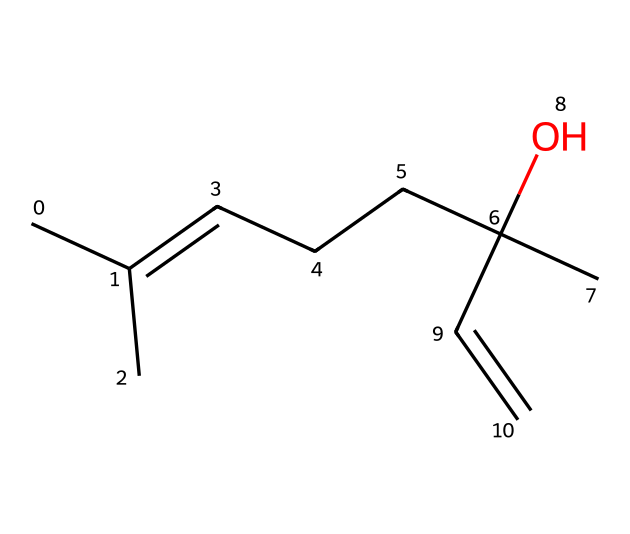What is the molecular formula of linalool? By analyzing the provided SMILES notation, we count the number of each type of atom. The structure indicates there are 10 carbon (C) atoms, 18 hydrogen (H) atoms, and 1 oxygen (O) atom. Therefore, the molecular formula is C10H18O.
Answer: C10H18O How many carbon atoms are present in linalool? Observing the SMILES representation, we can see the number of 'C' indicates the carbon atoms in the structure. Counting the 'C' in the SMILES leads us to a total of 10 carbon atoms.
Answer: 10 What type of functional group is indicated by the "C(O)" part of linalool? The "C(O)" portion in the SMILES notation represents a carbon atom bonded to a hydroxyl group (OH). This indicates the presence of an alcohol functional group in linalool.
Answer: alcohol Is linalool a cyclic or acyclic compound? By examining the structure, we can see there are no ring structures present as indicated by the absence of a cycle in the carbon chain from the SMILES. This confirms that linalool is an acyclic compound.
Answer: acyclic What is the primary reason linalool is used in stress relief? Linalool is commonly known for its calming and relaxing properties due to its interaction with the nervous system and its aromatic profile. This property is primarily linked to its specific arrangement of atoms and bonds which influences how it interacts with biological targets.
Answer: calming What distinguishes linalool as a terpene compared to other organic compounds? Terpenes are characterized by their structure, consisting of isoprene units. Linalool has a specific arrangement of carbon atoms, along with double bonds and functional groups consistent with terpene classification. This structural feature is key in identifying it as a terpene.
Answer: isoprene units 